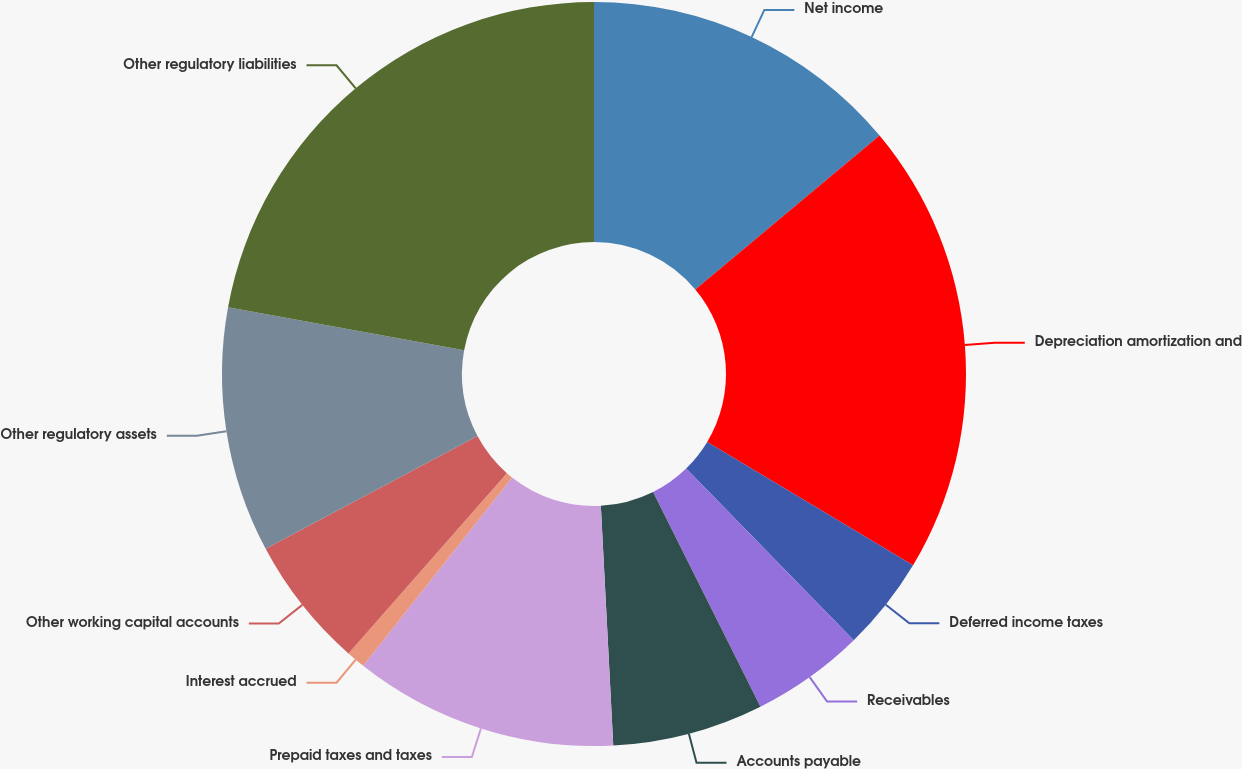Convert chart. <chart><loc_0><loc_0><loc_500><loc_500><pie_chart><fcel>Net income<fcel>Depreciation amortization and<fcel>Deferred income taxes<fcel>Receivables<fcel>Accounts payable<fcel>Prepaid taxes and taxes<fcel>Interest accrued<fcel>Other working capital accounts<fcel>Other regulatory assets<fcel>Other regulatory liabilities<nl><fcel>13.93%<fcel>19.67%<fcel>4.1%<fcel>4.92%<fcel>6.56%<fcel>11.48%<fcel>0.82%<fcel>5.74%<fcel>10.66%<fcel>22.13%<nl></chart> 